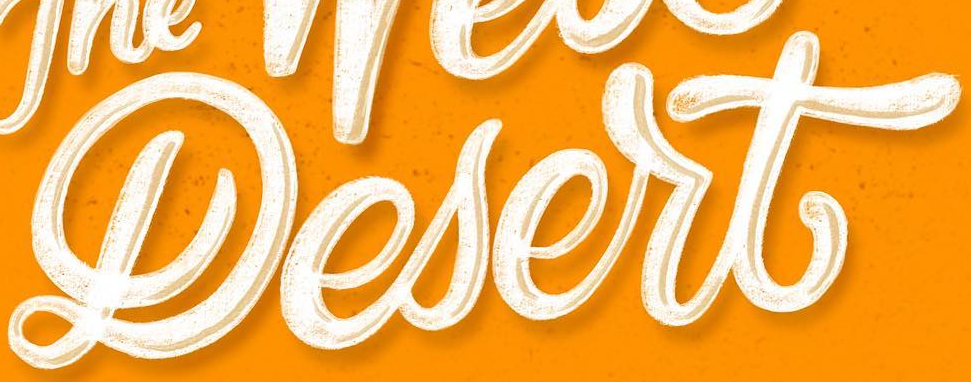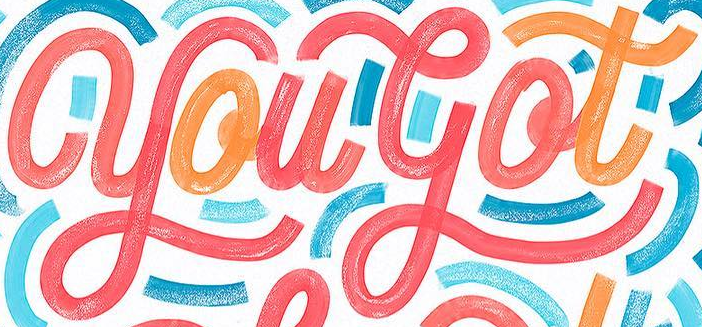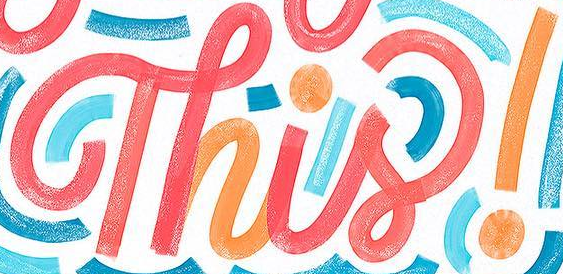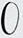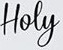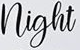Transcribe the words shown in these images in order, separated by a semicolon. Lesert; yougot; Thisǃ; O; Hoey; night 